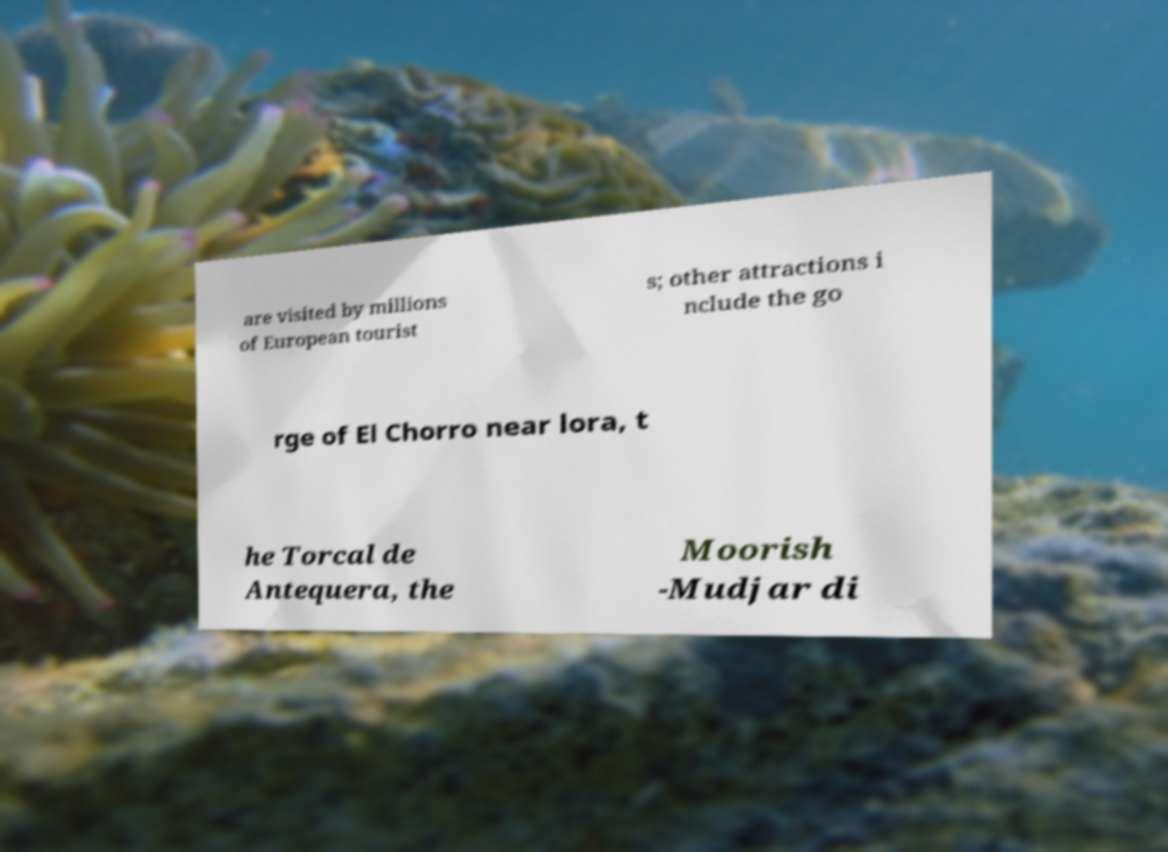Could you extract and type out the text from this image? are visited by millions of European tourist s; other attractions i nclude the go rge of El Chorro near lora, t he Torcal de Antequera, the Moorish -Mudjar di 